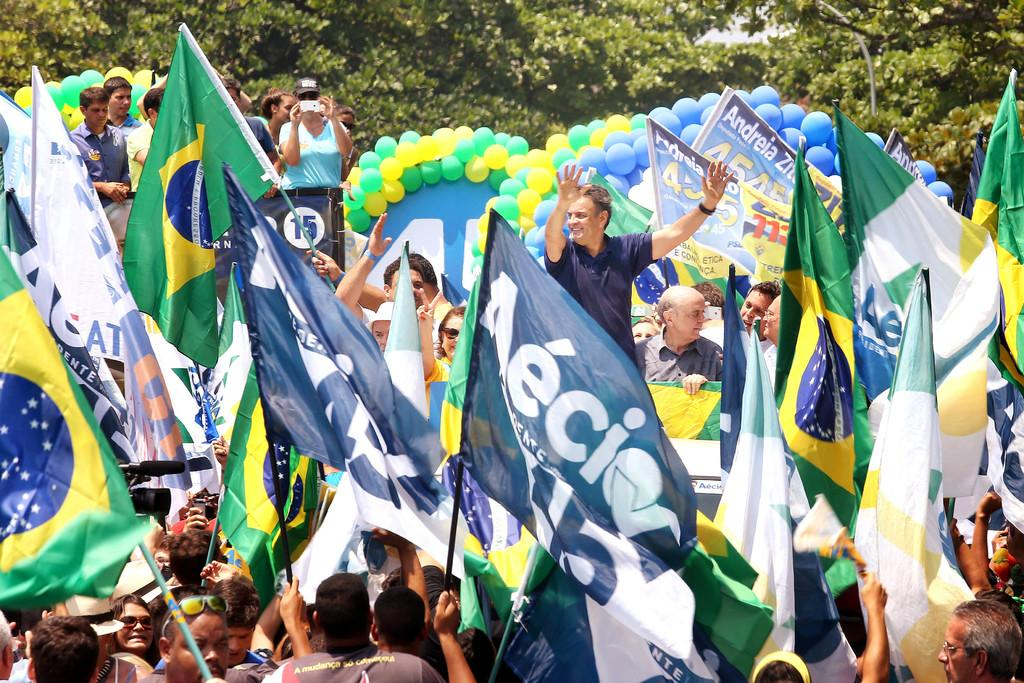How many people are in the image? There are people in the image, but the exact number is not specified. What are some people doing in the image? Some people are holding flags in the image. What other decorative items can be seen in the image? There are balloons and banners in the image. What can be seen in the background of the image? Trees are visible in the background of the image. How many feet are resting on the ground in the image? There is no information about feet or their position in the image, so we cannot answer this question. 